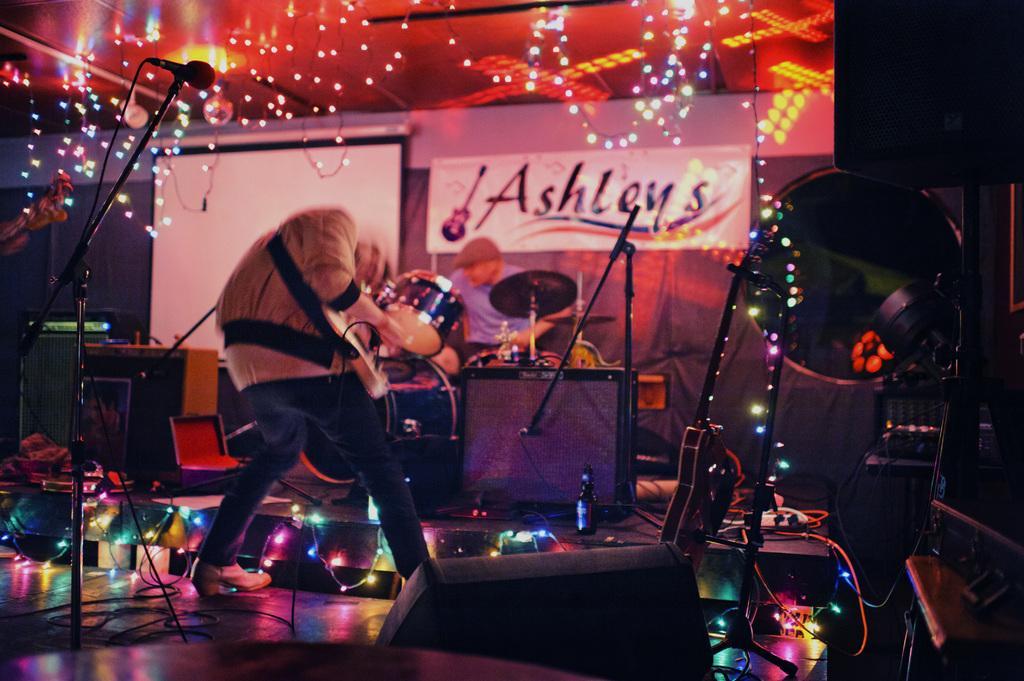How would you summarize this image in a sentence or two? In this image there is a person standing on the stage. Left side there is a mike stand. Middle of the image there is a person wearing a cap. Before him there are musical instruments. There is a bottle and few objects are on the stage. There are decorative lights on the stage. There is a board and a screen are attached to the wall. Top of the image lights are hanging from the roof. Right side there is a light on the stand. 